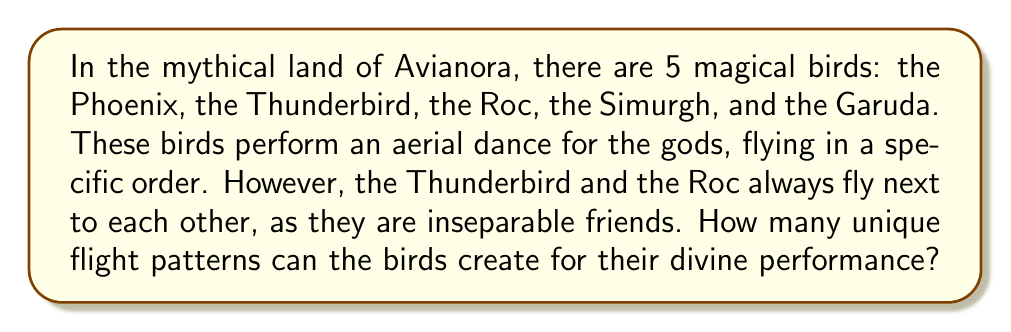Solve this math problem. To solve this problem, we'll use the concept of permutation groups with a restriction.

1) First, let's consider the Thunderbird and Roc as a single unit. This reduces our problem to arranging 4 elements: (Thunderbird-Roc unit), Phoenix, Simurgh, and Garuda.

2) The number of permutations of 4 distinct elements is given by:

   $$4! = 4 \times 3 \times 2 \times 1 = 24$$

3) However, we need to account for the fact that the Thunderbird and Roc can swap positions within their unit. For each of the 24 permutations, there are 2 ways to arrange the Thunderbird and Roc.

4) Therefore, we multiply our result by 2:

   $$24 \times 2 = 48$$

This can also be understood using the multiplication principle in group theory. If we denote the group of permutations of 4 elements as $S_4$ and the group of permutations of 2 elements as $S_2$, we are essentially calculating the order of the product group $S_4 \times S_2$:

$$|S_4 \times S_2| = |S_4| \times |S_2| = 24 \times 2 = 48$$

Thus, there are 48 unique flight patterns that the magical birds can create for their divine aerial dance.
Answer: 48 unique flight patterns 